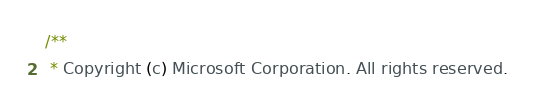Convert code to text. <code><loc_0><loc_0><loc_500><loc_500><_Java_>/**
 * Copyright (c) Microsoft Corporation. All rights reserved.</code> 